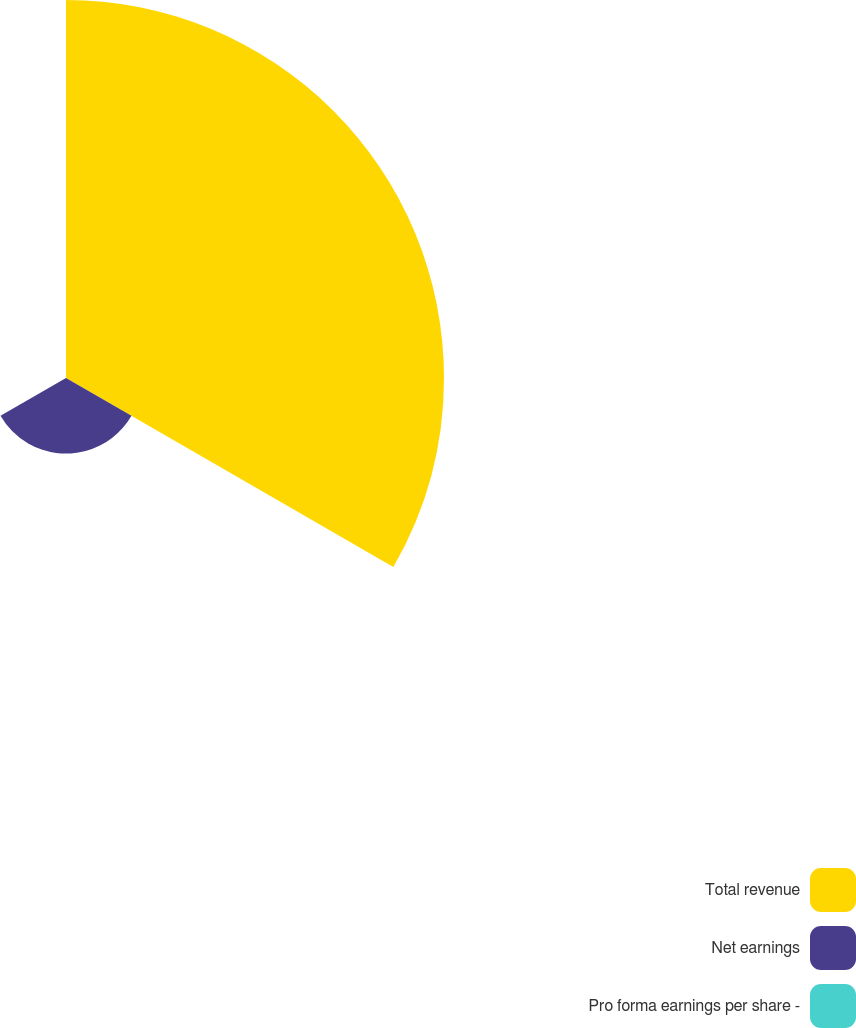Convert chart. <chart><loc_0><loc_0><loc_500><loc_500><pie_chart><fcel>Total revenue<fcel>Net earnings<fcel>Pro forma earnings per share -<nl><fcel>83.33%<fcel>16.67%<fcel>0.0%<nl></chart> 